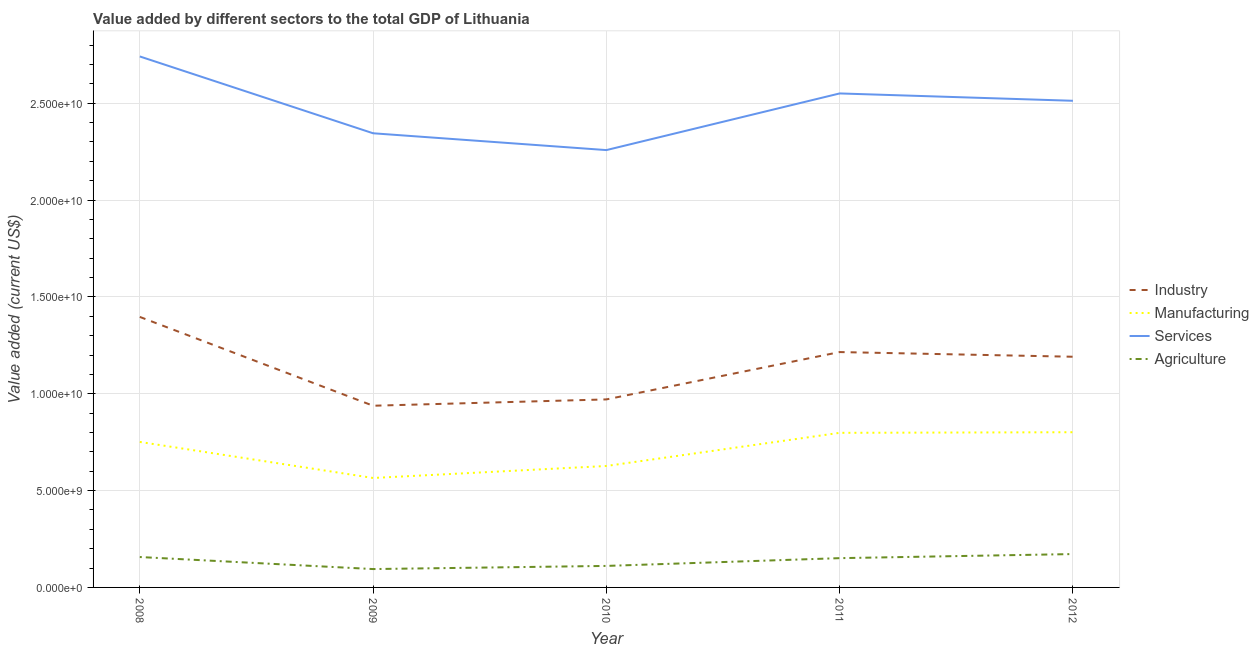Does the line corresponding to value added by services sector intersect with the line corresponding to value added by industrial sector?
Offer a terse response. No. What is the value added by services sector in 2008?
Offer a terse response. 2.74e+1. Across all years, what is the maximum value added by manufacturing sector?
Your response must be concise. 8.01e+09. Across all years, what is the minimum value added by agricultural sector?
Your answer should be very brief. 9.48e+08. In which year was the value added by agricultural sector minimum?
Your answer should be very brief. 2009. What is the total value added by agricultural sector in the graph?
Provide a succinct answer. 6.86e+09. What is the difference between the value added by industrial sector in 2008 and that in 2009?
Your answer should be very brief. 4.59e+09. What is the difference between the value added by agricultural sector in 2009 and the value added by industrial sector in 2010?
Offer a terse response. -8.76e+09. What is the average value added by manufacturing sector per year?
Offer a very short reply. 7.09e+09. In the year 2009, what is the difference between the value added by agricultural sector and value added by services sector?
Your answer should be compact. -2.25e+1. What is the ratio of the value added by industrial sector in 2008 to that in 2011?
Offer a terse response. 1.15. Is the difference between the value added by manufacturing sector in 2009 and 2011 greater than the difference between the value added by agricultural sector in 2009 and 2011?
Keep it short and to the point. No. What is the difference between the highest and the second highest value added by services sector?
Give a very brief answer. 1.91e+09. What is the difference between the highest and the lowest value added by services sector?
Provide a succinct answer. 4.83e+09. In how many years, is the value added by agricultural sector greater than the average value added by agricultural sector taken over all years?
Ensure brevity in your answer.  3. Is the sum of the value added by manufacturing sector in 2008 and 2011 greater than the maximum value added by industrial sector across all years?
Make the answer very short. Yes. Is it the case that in every year, the sum of the value added by agricultural sector and value added by manufacturing sector is greater than the sum of value added by services sector and value added by industrial sector?
Offer a terse response. Yes. Is it the case that in every year, the sum of the value added by industrial sector and value added by manufacturing sector is greater than the value added by services sector?
Your answer should be very brief. No. What is the difference between two consecutive major ticks on the Y-axis?
Ensure brevity in your answer.  5.00e+09. Where does the legend appear in the graph?
Your answer should be compact. Center right. How many legend labels are there?
Offer a terse response. 4. What is the title of the graph?
Offer a terse response. Value added by different sectors to the total GDP of Lithuania. What is the label or title of the X-axis?
Keep it short and to the point. Year. What is the label or title of the Y-axis?
Keep it short and to the point. Value added (current US$). What is the Value added (current US$) of Industry in 2008?
Keep it short and to the point. 1.40e+1. What is the Value added (current US$) of Manufacturing in 2008?
Your answer should be very brief. 7.51e+09. What is the Value added (current US$) of Services in 2008?
Your response must be concise. 2.74e+1. What is the Value added (current US$) in Agriculture in 2008?
Your response must be concise. 1.57e+09. What is the Value added (current US$) in Industry in 2009?
Your answer should be compact. 9.38e+09. What is the Value added (current US$) of Manufacturing in 2009?
Your answer should be very brief. 5.65e+09. What is the Value added (current US$) of Services in 2009?
Your answer should be compact. 2.34e+1. What is the Value added (current US$) in Agriculture in 2009?
Your answer should be compact. 9.48e+08. What is the Value added (current US$) in Industry in 2010?
Provide a short and direct response. 9.71e+09. What is the Value added (current US$) in Manufacturing in 2010?
Provide a succinct answer. 6.27e+09. What is the Value added (current US$) in Services in 2010?
Provide a succinct answer. 2.26e+1. What is the Value added (current US$) of Agriculture in 2010?
Your answer should be very brief. 1.11e+09. What is the Value added (current US$) of Industry in 2011?
Make the answer very short. 1.22e+1. What is the Value added (current US$) of Manufacturing in 2011?
Make the answer very short. 7.98e+09. What is the Value added (current US$) in Services in 2011?
Give a very brief answer. 2.55e+1. What is the Value added (current US$) of Agriculture in 2011?
Your response must be concise. 1.51e+09. What is the Value added (current US$) of Industry in 2012?
Your response must be concise. 1.19e+1. What is the Value added (current US$) in Manufacturing in 2012?
Keep it short and to the point. 8.01e+09. What is the Value added (current US$) in Services in 2012?
Make the answer very short. 2.51e+1. What is the Value added (current US$) of Agriculture in 2012?
Offer a very short reply. 1.72e+09. Across all years, what is the maximum Value added (current US$) in Industry?
Provide a short and direct response. 1.40e+1. Across all years, what is the maximum Value added (current US$) of Manufacturing?
Your answer should be compact. 8.01e+09. Across all years, what is the maximum Value added (current US$) in Services?
Provide a succinct answer. 2.74e+1. Across all years, what is the maximum Value added (current US$) in Agriculture?
Provide a succinct answer. 1.72e+09. Across all years, what is the minimum Value added (current US$) in Industry?
Your response must be concise. 9.38e+09. Across all years, what is the minimum Value added (current US$) of Manufacturing?
Ensure brevity in your answer.  5.65e+09. Across all years, what is the minimum Value added (current US$) in Services?
Your answer should be very brief. 2.26e+1. Across all years, what is the minimum Value added (current US$) in Agriculture?
Provide a succinct answer. 9.48e+08. What is the total Value added (current US$) in Industry in the graph?
Give a very brief answer. 5.71e+1. What is the total Value added (current US$) of Manufacturing in the graph?
Provide a succinct answer. 3.54e+1. What is the total Value added (current US$) in Services in the graph?
Provide a succinct answer. 1.24e+11. What is the total Value added (current US$) of Agriculture in the graph?
Ensure brevity in your answer.  6.86e+09. What is the difference between the Value added (current US$) of Industry in 2008 and that in 2009?
Give a very brief answer. 4.59e+09. What is the difference between the Value added (current US$) of Manufacturing in 2008 and that in 2009?
Ensure brevity in your answer.  1.86e+09. What is the difference between the Value added (current US$) of Services in 2008 and that in 2009?
Make the answer very short. 3.97e+09. What is the difference between the Value added (current US$) in Agriculture in 2008 and that in 2009?
Your response must be concise. 6.21e+08. What is the difference between the Value added (current US$) of Industry in 2008 and that in 2010?
Give a very brief answer. 4.26e+09. What is the difference between the Value added (current US$) of Manufacturing in 2008 and that in 2010?
Give a very brief answer. 1.24e+09. What is the difference between the Value added (current US$) in Services in 2008 and that in 2010?
Your response must be concise. 4.83e+09. What is the difference between the Value added (current US$) in Agriculture in 2008 and that in 2010?
Ensure brevity in your answer.  4.59e+08. What is the difference between the Value added (current US$) in Industry in 2008 and that in 2011?
Offer a terse response. 1.81e+09. What is the difference between the Value added (current US$) in Manufacturing in 2008 and that in 2011?
Offer a very short reply. -4.70e+08. What is the difference between the Value added (current US$) of Services in 2008 and that in 2011?
Keep it short and to the point. 1.91e+09. What is the difference between the Value added (current US$) in Agriculture in 2008 and that in 2011?
Offer a terse response. 5.78e+07. What is the difference between the Value added (current US$) of Industry in 2008 and that in 2012?
Give a very brief answer. 2.06e+09. What is the difference between the Value added (current US$) of Manufacturing in 2008 and that in 2012?
Your response must be concise. -5.01e+08. What is the difference between the Value added (current US$) in Services in 2008 and that in 2012?
Keep it short and to the point. 2.29e+09. What is the difference between the Value added (current US$) of Agriculture in 2008 and that in 2012?
Your answer should be compact. -1.53e+08. What is the difference between the Value added (current US$) in Industry in 2009 and that in 2010?
Make the answer very short. -3.26e+08. What is the difference between the Value added (current US$) in Manufacturing in 2009 and that in 2010?
Make the answer very short. -6.19e+08. What is the difference between the Value added (current US$) of Services in 2009 and that in 2010?
Keep it short and to the point. 8.68e+08. What is the difference between the Value added (current US$) of Agriculture in 2009 and that in 2010?
Keep it short and to the point. -1.62e+08. What is the difference between the Value added (current US$) of Industry in 2009 and that in 2011?
Provide a succinct answer. -2.77e+09. What is the difference between the Value added (current US$) in Manufacturing in 2009 and that in 2011?
Offer a very short reply. -2.33e+09. What is the difference between the Value added (current US$) of Services in 2009 and that in 2011?
Ensure brevity in your answer.  -2.06e+09. What is the difference between the Value added (current US$) in Agriculture in 2009 and that in 2011?
Ensure brevity in your answer.  -5.63e+08. What is the difference between the Value added (current US$) in Industry in 2009 and that in 2012?
Provide a short and direct response. -2.53e+09. What is the difference between the Value added (current US$) in Manufacturing in 2009 and that in 2012?
Make the answer very short. -2.36e+09. What is the difference between the Value added (current US$) of Services in 2009 and that in 2012?
Ensure brevity in your answer.  -1.68e+09. What is the difference between the Value added (current US$) in Agriculture in 2009 and that in 2012?
Your answer should be compact. -7.74e+08. What is the difference between the Value added (current US$) of Industry in 2010 and that in 2011?
Provide a short and direct response. -2.44e+09. What is the difference between the Value added (current US$) in Manufacturing in 2010 and that in 2011?
Keep it short and to the point. -1.71e+09. What is the difference between the Value added (current US$) of Services in 2010 and that in 2011?
Your answer should be compact. -2.93e+09. What is the difference between the Value added (current US$) in Agriculture in 2010 and that in 2011?
Provide a short and direct response. -4.01e+08. What is the difference between the Value added (current US$) in Industry in 2010 and that in 2012?
Your answer should be very brief. -2.20e+09. What is the difference between the Value added (current US$) in Manufacturing in 2010 and that in 2012?
Your answer should be compact. -1.74e+09. What is the difference between the Value added (current US$) of Services in 2010 and that in 2012?
Your answer should be compact. -2.55e+09. What is the difference between the Value added (current US$) in Agriculture in 2010 and that in 2012?
Keep it short and to the point. -6.12e+08. What is the difference between the Value added (current US$) of Industry in 2011 and that in 2012?
Make the answer very short. 2.42e+08. What is the difference between the Value added (current US$) of Manufacturing in 2011 and that in 2012?
Offer a terse response. -3.11e+07. What is the difference between the Value added (current US$) of Services in 2011 and that in 2012?
Provide a short and direct response. 3.79e+08. What is the difference between the Value added (current US$) in Agriculture in 2011 and that in 2012?
Offer a very short reply. -2.11e+08. What is the difference between the Value added (current US$) of Industry in 2008 and the Value added (current US$) of Manufacturing in 2009?
Your response must be concise. 8.32e+09. What is the difference between the Value added (current US$) in Industry in 2008 and the Value added (current US$) in Services in 2009?
Provide a succinct answer. -9.48e+09. What is the difference between the Value added (current US$) in Industry in 2008 and the Value added (current US$) in Agriculture in 2009?
Your answer should be compact. 1.30e+1. What is the difference between the Value added (current US$) in Manufacturing in 2008 and the Value added (current US$) in Services in 2009?
Offer a very short reply. -1.59e+1. What is the difference between the Value added (current US$) in Manufacturing in 2008 and the Value added (current US$) in Agriculture in 2009?
Your answer should be compact. 6.56e+09. What is the difference between the Value added (current US$) in Services in 2008 and the Value added (current US$) in Agriculture in 2009?
Provide a succinct answer. 2.65e+1. What is the difference between the Value added (current US$) in Industry in 2008 and the Value added (current US$) in Manufacturing in 2010?
Your answer should be compact. 7.70e+09. What is the difference between the Value added (current US$) in Industry in 2008 and the Value added (current US$) in Services in 2010?
Make the answer very short. -8.61e+09. What is the difference between the Value added (current US$) of Industry in 2008 and the Value added (current US$) of Agriculture in 2010?
Your answer should be compact. 1.29e+1. What is the difference between the Value added (current US$) of Manufacturing in 2008 and the Value added (current US$) of Services in 2010?
Your answer should be compact. -1.51e+1. What is the difference between the Value added (current US$) in Manufacturing in 2008 and the Value added (current US$) in Agriculture in 2010?
Provide a short and direct response. 6.40e+09. What is the difference between the Value added (current US$) in Services in 2008 and the Value added (current US$) in Agriculture in 2010?
Keep it short and to the point. 2.63e+1. What is the difference between the Value added (current US$) of Industry in 2008 and the Value added (current US$) of Manufacturing in 2011?
Keep it short and to the point. 5.98e+09. What is the difference between the Value added (current US$) in Industry in 2008 and the Value added (current US$) in Services in 2011?
Give a very brief answer. -1.15e+1. What is the difference between the Value added (current US$) of Industry in 2008 and the Value added (current US$) of Agriculture in 2011?
Provide a succinct answer. 1.25e+1. What is the difference between the Value added (current US$) of Manufacturing in 2008 and the Value added (current US$) of Services in 2011?
Offer a very short reply. -1.80e+1. What is the difference between the Value added (current US$) in Manufacturing in 2008 and the Value added (current US$) in Agriculture in 2011?
Provide a succinct answer. 6.00e+09. What is the difference between the Value added (current US$) in Services in 2008 and the Value added (current US$) in Agriculture in 2011?
Offer a very short reply. 2.59e+1. What is the difference between the Value added (current US$) of Industry in 2008 and the Value added (current US$) of Manufacturing in 2012?
Give a very brief answer. 5.95e+09. What is the difference between the Value added (current US$) in Industry in 2008 and the Value added (current US$) in Services in 2012?
Give a very brief answer. -1.12e+1. What is the difference between the Value added (current US$) of Industry in 2008 and the Value added (current US$) of Agriculture in 2012?
Your answer should be very brief. 1.22e+1. What is the difference between the Value added (current US$) of Manufacturing in 2008 and the Value added (current US$) of Services in 2012?
Provide a short and direct response. -1.76e+1. What is the difference between the Value added (current US$) of Manufacturing in 2008 and the Value added (current US$) of Agriculture in 2012?
Offer a terse response. 5.79e+09. What is the difference between the Value added (current US$) of Services in 2008 and the Value added (current US$) of Agriculture in 2012?
Keep it short and to the point. 2.57e+1. What is the difference between the Value added (current US$) of Industry in 2009 and the Value added (current US$) of Manufacturing in 2010?
Make the answer very short. 3.11e+09. What is the difference between the Value added (current US$) of Industry in 2009 and the Value added (current US$) of Services in 2010?
Ensure brevity in your answer.  -1.32e+1. What is the difference between the Value added (current US$) of Industry in 2009 and the Value added (current US$) of Agriculture in 2010?
Provide a short and direct response. 8.27e+09. What is the difference between the Value added (current US$) of Manufacturing in 2009 and the Value added (current US$) of Services in 2010?
Ensure brevity in your answer.  -1.69e+1. What is the difference between the Value added (current US$) in Manufacturing in 2009 and the Value added (current US$) in Agriculture in 2010?
Ensure brevity in your answer.  4.54e+09. What is the difference between the Value added (current US$) of Services in 2009 and the Value added (current US$) of Agriculture in 2010?
Make the answer very short. 2.23e+1. What is the difference between the Value added (current US$) in Industry in 2009 and the Value added (current US$) in Manufacturing in 2011?
Your answer should be very brief. 1.40e+09. What is the difference between the Value added (current US$) of Industry in 2009 and the Value added (current US$) of Services in 2011?
Keep it short and to the point. -1.61e+1. What is the difference between the Value added (current US$) of Industry in 2009 and the Value added (current US$) of Agriculture in 2011?
Your answer should be very brief. 7.87e+09. What is the difference between the Value added (current US$) of Manufacturing in 2009 and the Value added (current US$) of Services in 2011?
Make the answer very short. -1.99e+1. What is the difference between the Value added (current US$) in Manufacturing in 2009 and the Value added (current US$) in Agriculture in 2011?
Your answer should be very brief. 4.14e+09. What is the difference between the Value added (current US$) in Services in 2009 and the Value added (current US$) in Agriculture in 2011?
Offer a terse response. 2.19e+1. What is the difference between the Value added (current US$) in Industry in 2009 and the Value added (current US$) in Manufacturing in 2012?
Offer a terse response. 1.37e+09. What is the difference between the Value added (current US$) in Industry in 2009 and the Value added (current US$) in Services in 2012?
Your answer should be compact. -1.57e+1. What is the difference between the Value added (current US$) in Industry in 2009 and the Value added (current US$) in Agriculture in 2012?
Your response must be concise. 7.66e+09. What is the difference between the Value added (current US$) in Manufacturing in 2009 and the Value added (current US$) in Services in 2012?
Your response must be concise. -1.95e+1. What is the difference between the Value added (current US$) of Manufacturing in 2009 and the Value added (current US$) of Agriculture in 2012?
Provide a short and direct response. 3.93e+09. What is the difference between the Value added (current US$) in Services in 2009 and the Value added (current US$) in Agriculture in 2012?
Give a very brief answer. 2.17e+1. What is the difference between the Value added (current US$) in Industry in 2010 and the Value added (current US$) in Manufacturing in 2011?
Your response must be concise. 1.73e+09. What is the difference between the Value added (current US$) in Industry in 2010 and the Value added (current US$) in Services in 2011?
Your answer should be compact. -1.58e+1. What is the difference between the Value added (current US$) in Industry in 2010 and the Value added (current US$) in Agriculture in 2011?
Provide a succinct answer. 8.20e+09. What is the difference between the Value added (current US$) of Manufacturing in 2010 and the Value added (current US$) of Services in 2011?
Your response must be concise. -1.92e+1. What is the difference between the Value added (current US$) of Manufacturing in 2010 and the Value added (current US$) of Agriculture in 2011?
Offer a terse response. 4.76e+09. What is the difference between the Value added (current US$) of Services in 2010 and the Value added (current US$) of Agriculture in 2011?
Your answer should be compact. 2.11e+1. What is the difference between the Value added (current US$) of Industry in 2010 and the Value added (current US$) of Manufacturing in 2012?
Provide a succinct answer. 1.69e+09. What is the difference between the Value added (current US$) in Industry in 2010 and the Value added (current US$) in Services in 2012?
Ensure brevity in your answer.  -1.54e+1. What is the difference between the Value added (current US$) of Industry in 2010 and the Value added (current US$) of Agriculture in 2012?
Make the answer very short. 7.99e+09. What is the difference between the Value added (current US$) in Manufacturing in 2010 and the Value added (current US$) in Services in 2012?
Offer a very short reply. -1.89e+1. What is the difference between the Value added (current US$) in Manufacturing in 2010 and the Value added (current US$) in Agriculture in 2012?
Provide a succinct answer. 4.55e+09. What is the difference between the Value added (current US$) in Services in 2010 and the Value added (current US$) in Agriculture in 2012?
Make the answer very short. 2.09e+1. What is the difference between the Value added (current US$) of Industry in 2011 and the Value added (current US$) of Manufacturing in 2012?
Ensure brevity in your answer.  4.14e+09. What is the difference between the Value added (current US$) in Industry in 2011 and the Value added (current US$) in Services in 2012?
Your answer should be very brief. -1.30e+1. What is the difference between the Value added (current US$) of Industry in 2011 and the Value added (current US$) of Agriculture in 2012?
Keep it short and to the point. 1.04e+1. What is the difference between the Value added (current US$) in Manufacturing in 2011 and the Value added (current US$) in Services in 2012?
Your answer should be very brief. -1.71e+1. What is the difference between the Value added (current US$) of Manufacturing in 2011 and the Value added (current US$) of Agriculture in 2012?
Make the answer very short. 6.26e+09. What is the difference between the Value added (current US$) in Services in 2011 and the Value added (current US$) in Agriculture in 2012?
Your answer should be compact. 2.38e+1. What is the average Value added (current US$) in Industry per year?
Provide a succinct answer. 1.14e+1. What is the average Value added (current US$) of Manufacturing per year?
Make the answer very short. 7.09e+09. What is the average Value added (current US$) in Services per year?
Make the answer very short. 2.48e+1. What is the average Value added (current US$) in Agriculture per year?
Your answer should be compact. 1.37e+09. In the year 2008, what is the difference between the Value added (current US$) in Industry and Value added (current US$) in Manufacturing?
Ensure brevity in your answer.  6.46e+09. In the year 2008, what is the difference between the Value added (current US$) in Industry and Value added (current US$) in Services?
Offer a terse response. -1.34e+1. In the year 2008, what is the difference between the Value added (current US$) of Industry and Value added (current US$) of Agriculture?
Your answer should be compact. 1.24e+1. In the year 2008, what is the difference between the Value added (current US$) in Manufacturing and Value added (current US$) in Services?
Ensure brevity in your answer.  -1.99e+1. In the year 2008, what is the difference between the Value added (current US$) in Manufacturing and Value added (current US$) in Agriculture?
Ensure brevity in your answer.  5.94e+09. In the year 2008, what is the difference between the Value added (current US$) of Services and Value added (current US$) of Agriculture?
Offer a terse response. 2.58e+1. In the year 2009, what is the difference between the Value added (current US$) of Industry and Value added (current US$) of Manufacturing?
Your answer should be compact. 3.73e+09. In the year 2009, what is the difference between the Value added (current US$) in Industry and Value added (current US$) in Services?
Your answer should be compact. -1.41e+1. In the year 2009, what is the difference between the Value added (current US$) of Industry and Value added (current US$) of Agriculture?
Give a very brief answer. 8.43e+09. In the year 2009, what is the difference between the Value added (current US$) of Manufacturing and Value added (current US$) of Services?
Your response must be concise. -1.78e+1. In the year 2009, what is the difference between the Value added (current US$) in Manufacturing and Value added (current US$) in Agriculture?
Your answer should be compact. 4.70e+09. In the year 2009, what is the difference between the Value added (current US$) in Services and Value added (current US$) in Agriculture?
Your answer should be compact. 2.25e+1. In the year 2010, what is the difference between the Value added (current US$) in Industry and Value added (current US$) in Manufacturing?
Keep it short and to the point. 3.44e+09. In the year 2010, what is the difference between the Value added (current US$) of Industry and Value added (current US$) of Services?
Your response must be concise. -1.29e+1. In the year 2010, what is the difference between the Value added (current US$) of Industry and Value added (current US$) of Agriculture?
Keep it short and to the point. 8.60e+09. In the year 2010, what is the difference between the Value added (current US$) in Manufacturing and Value added (current US$) in Services?
Ensure brevity in your answer.  -1.63e+1. In the year 2010, what is the difference between the Value added (current US$) in Manufacturing and Value added (current US$) in Agriculture?
Make the answer very short. 5.16e+09. In the year 2010, what is the difference between the Value added (current US$) of Services and Value added (current US$) of Agriculture?
Your answer should be very brief. 2.15e+1. In the year 2011, what is the difference between the Value added (current US$) in Industry and Value added (current US$) in Manufacturing?
Ensure brevity in your answer.  4.17e+09. In the year 2011, what is the difference between the Value added (current US$) in Industry and Value added (current US$) in Services?
Make the answer very short. -1.34e+1. In the year 2011, what is the difference between the Value added (current US$) of Industry and Value added (current US$) of Agriculture?
Your answer should be compact. 1.06e+1. In the year 2011, what is the difference between the Value added (current US$) of Manufacturing and Value added (current US$) of Services?
Your answer should be compact. -1.75e+1. In the year 2011, what is the difference between the Value added (current US$) in Manufacturing and Value added (current US$) in Agriculture?
Provide a succinct answer. 6.47e+09. In the year 2011, what is the difference between the Value added (current US$) in Services and Value added (current US$) in Agriculture?
Provide a succinct answer. 2.40e+1. In the year 2012, what is the difference between the Value added (current US$) in Industry and Value added (current US$) in Manufacturing?
Give a very brief answer. 3.90e+09. In the year 2012, what is the difference between the Value added (current US$) of Industry and Value added (current US$) of Services?
Offer a terse response. -1.32e+1. In the year 2012, what is the difference between the Value added (current US$) of Industry and Value added (current US$) of Agriculture?
Give a very brief answer. 1.02e+1. In the year 2012, what is the difference between the Value added (current US$) in Manufacturing and Value added (current US$) in Services?
Your answer should be compact. -1.71e+1. In the year 2012, what is the difference between the Value added (current US$) in Manufacturing and Value added (current US$) in Agriculture?
Give a very brief answer. 6.29e+09. In the year 2012, what is the difference between the Value added (current US$) of Services and Value added (current US$) of Agriculture?
Provide a succinct answer. 2.34e+1. What is the ratio of the Value added (current US$) of Industry in 2008 to that in 2009?
Your response must be concise. 1.49. What is the ratio of the Value added (current US$) of Manufacturing in 2008 to that in 2009?
Offer a very short reply. 1.33. What is the ratio of the Value added (current US$) of Services in 2008 to that in 2009?
Your answer should be very brief. 1.17. What is the ratio of the Value added (current US$) in Agriculture in 2008 to that in 2009?
Offer a very short reply. 1.66. What is the ratio of the Value added (current US$) in Industry in 2008 to that in 2010?
Your answer should be compact. 1.44. What is the ratio of the Value added (current US$) in Manufacturing in 2008 to that in 2010?
Make the answer very short. 1.2. What is the ratio of the Value added (current US$) in Services in 2008 to that in 2010?
Your response must be concise. 1.21. What is the ratio of the Value added (current US$) in Agriculture in 2008 to that in 2010?
Offer a very short reply. 1.41. What is the ratio of the Value added (current US$) in Industry in 2008 to that in 2011?
Ensure brevity in your answer.  1.15. What is the ratio of the Value added (current US$) of Manufacturing in 2008 to that in 2011?
Your response must be concise. 0.94. What is the ratio of the Value added (current US$) of Services in 2008 to that in 2011?
Ensure brevity in your answer.  1.07. What is the ratio of the Value added (current US$) of Agriculture in 2008 to that in 2011?
Provide a short and direct response. 1.04. What is the ratio of the Value added (current US$) in Industry in 2008 to that in 2012?
Ensure brevity in your answer.  1.17. What is the ratio of the Value added (current US$) of Manufacturing in 2008 to that in 2012?
Give a very brief answer. 0.94. What is the ratio of the Value added (current US$) of Services in 2008 to that in 2012?
Keep it short and to the point. 1.09. What is the ratio of the Value added (current US$) of Agriculture in 2008 to that in 2012?
Your answer should be compact. 0.91. What is the ratio of the Value added (current US$) of Industry in 2009 to that in 2010?
Provide a short and direct response. 0.97. What is the ratio of the Value added (current US$) in Manufacturing in 2009 to that in 2010?
Give a very brief answer. 0.9. What is the ratio of the Value added (current US$) in Services in 2009 to that in 2010?
Your answer should be compact. 1.04. What is the ratio of the Value added (current US$) of Agriculture in 2009 to that in 2010?
Provide a short and direct response. 0.85. What is the ratio of the Value added (current US$) of Industry in 2009 to that in 2011?
Provide a succinct answer. 0.77. What is the ratio of the Value added (current US$) in Manufacturing in 2009 to that in 2011?
Provide a short and direct response. 0.71. What is the ratio of the Value added (current US$) in Services in 2009 to that in 2011?
Give a very brief answer. 0.92. What is the ratio of the Value added (current US$) of Agriculture in 2009 to that in 2011?
Ensure brevity in your answer.  0.63. What is the ratio of the Value added (current US$) in Industry in 2009 to that in 2012?
Your answer should be compact. 0.79. What is the ratio of the Value added (current US$) of Manufacturing in 2009 to that in 2012?
Your answer should be very brief. 0.71. What is the ratio of the Value added (current US$) in Services in 2009 to that in 2012?
Ensure brevity in your answer.  0.93. What is the ratio of the Value added (current US$) of Agriculture in 2009 to that in 2012?
Ensure brevity in your answer.  0.55. What is the ratio of the Value added (current US$) in Industry in 2010 to that in 2011?
Provide a succinct answer. 0.8. What is the ratio of the Value added (current US$) in Manufacturing in 2010 to that in 2011?
Provide a short and direct response. 0.79. What is the ratio of the Value added (current US$) of Services in 2010 to that in 2011?
Give a very brief answer. 0.89. What is the ratio of the Value added (current US$) of Agriculture in 2010 to that in 2011?
Provide a short and direct response. 0.73. What is the ratio of the Value added (current US$) in Industry in 2010 to that in 2012?
Your answer should be very brief. 0.81. What is the ratio of the Value added (current US$) of Manufacturing in 2010 to that in 2012?
Your answer should be very brief. 0.78. What is the ratio of the Value added (current US$) of Services in 2010 to that in 2012?
Your answer should be compact. 0.9. What is the ratio of the Value added (current US$) of Agriculture in 2010 to that in 2012?
Provide a short and direct response. 0.64. What is the ratio of the Value added (current US$) of Industry in 2011 to that in 2012?
Offer a terse response. 1.02. What is the ratio of the Value added (current US$) of Services in 2011 to that in 2012?
Ensure brevity in your answer.  1.02. What is the ratio of the Value added (current US$) in Agriculture in 2011 to that in 2012?
Offer a very short reply. 0.88. What is the difference between the highest and the second highest Value added (current US$) of Industry?
Keep it short and to the point. 1.81e+09. What is the difference between the highest and the second highest Value added (current US$) of Manufacturing?
Offer a terse response. 3.11e+07. What is the difference between the highest and the second highest Value added (current US$) of Services?
Ensure brevity in your answer.  1.91e+09. What is the difference between the highest and the second highest Value added (current US$) in Agriculture?
Your response must be concise. 1.53e+08. What is the difference between the highest and the lowest Value added (current US$) in Industry?
Keep it short and to the point. 4.59e+09. What is the difference between the highest and the lowest Value added (current US$) of Manufacturing?
Give a very brief answer. 2.36e+09. What is the difference between the highest and the lowest Value added (current US$) in Services?
Provide a succinct answer. 4.83e+09. What is the difference between the highest and the lowest Value added (current US$) in Agriculture?
Your response must be concise. 7.74e+08. 